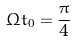<formula> <loc_0><loc_0><loc_500><loc_500>\Omega t _ { 0 } = \frac { \pi } { 4 }</formula> 